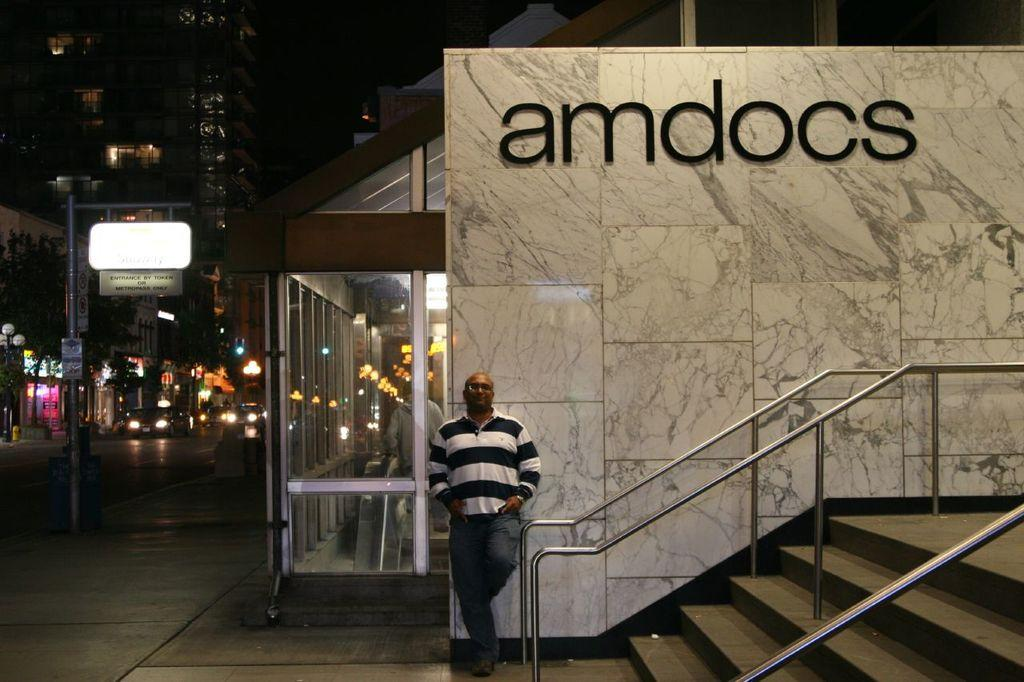What is the main subject of the image? There is a man standing in the middle of the image. What can be seen on the right side of the image? There are stairs on the right side of the image. What is the background of the image composed of? There is a wall in the image, and a building is visible. What is present on the left side of the image? There are cars on the left side of the image. Can you see a stranger in the image? There is no stranger present in the image. --- Facts: 1. There is a person in the image. 12. The person is wearing a hat. 13. The person is holding a book. 14. There is a table in the image. 15. There is a chair in the image. Absurd Topics: elephant, parrot, monkey Conversation: Who or what is the main subject in the image? There is a person in the image. What is the person wearing in the image? The person is wearing a hat. What is the person holding in the image? The person is holding a book. What other objects can be seen in the image? There is a table in the image, and there is a chair in the image. Reasoning: Let's think step by step in order to produce the conversation. We start by identifying the main subject of the image, which is the person. Then, we describe the person's attire, specifically mentioning the hat. Next, we observe what the person is holding, which is a book. Finally, we describe the other objects present in the image, which are the table and the chair. Absurd Question/Answer: Can you see an elephant, a parrot, or a monkey in the image? There is no elephant, parrot, or monkey present in the image. 